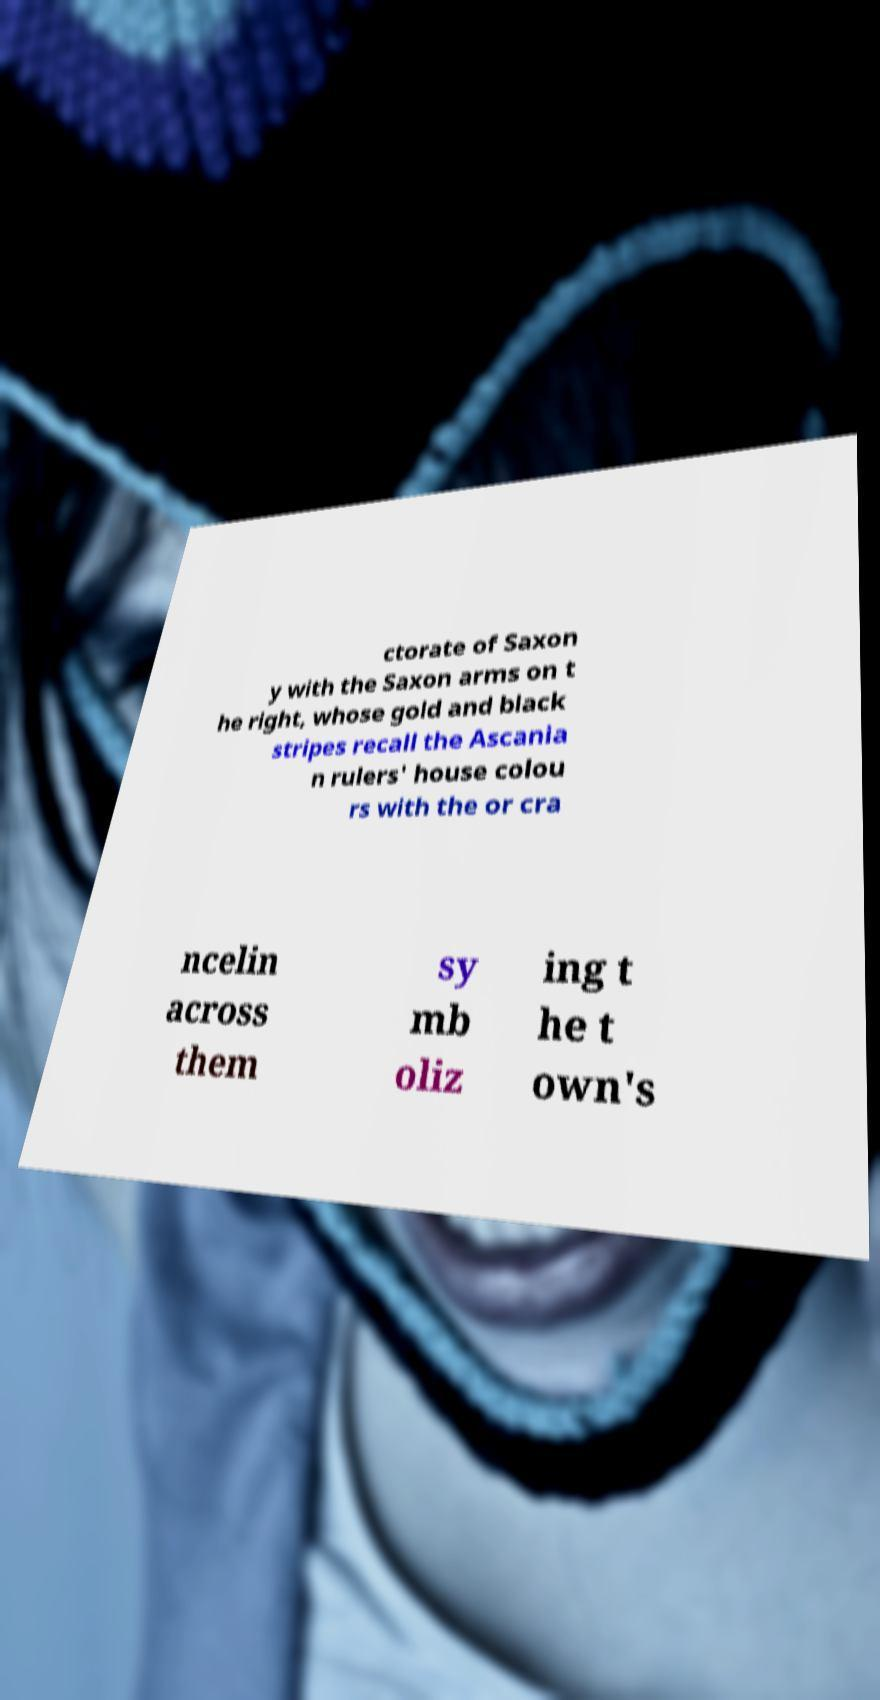Please read and relay the text visible in this image. What does it say? ctorate of Saxon y with the Saxon arms on t he right, whose gold and black stripes recall the Ascania n rulers' house colou rs with the or cra ncelin across them sy mb oliz ing t he t own's 